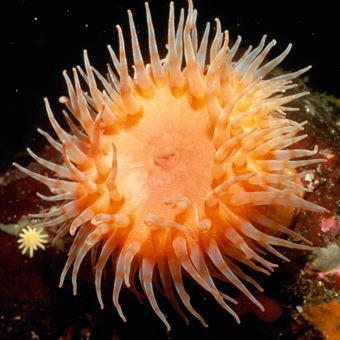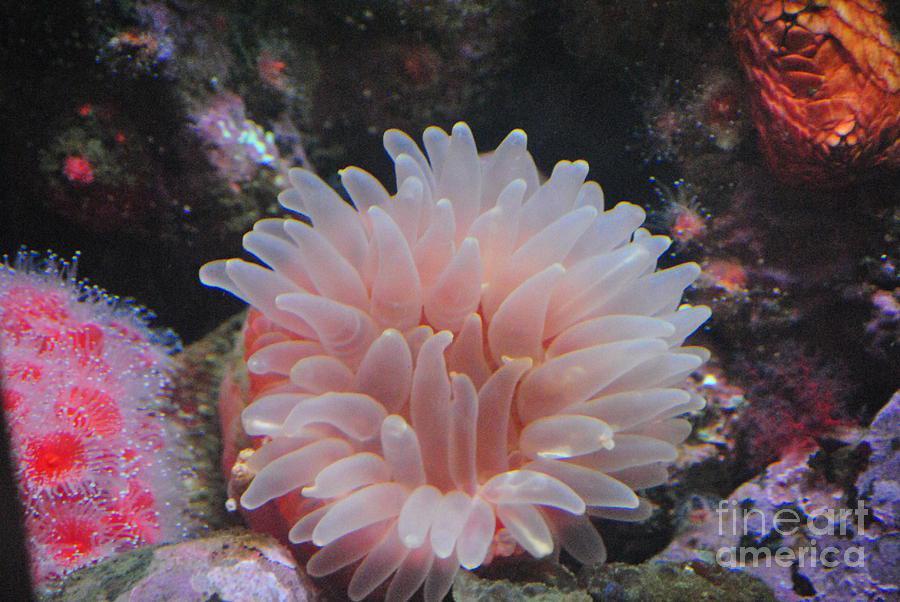The first image is the image on the left, the second image is the image on the right. Analyze the images presented: Is the assertion "The anemone in one of the images is a translucent pink." valid? Answer yes or no. Yes. 